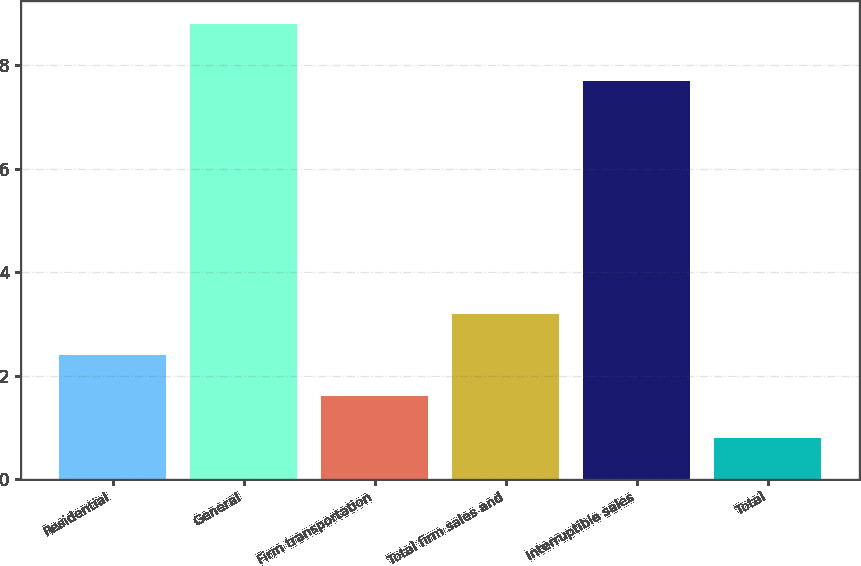Convert chart. <chart><loc_0><loc_0><loc_500><loc_500><bar_chart><fcel>Residential<fcel>General<fcel>Firm transportation<fcel>Total firm sales and<fcel>Interruptible sales<fcel>Total<nl><fcel>2.4<fcel>8.8<fcel>1.6<fcel>3.2<fcel>7.7<fcel>0.8<nl></chart> 